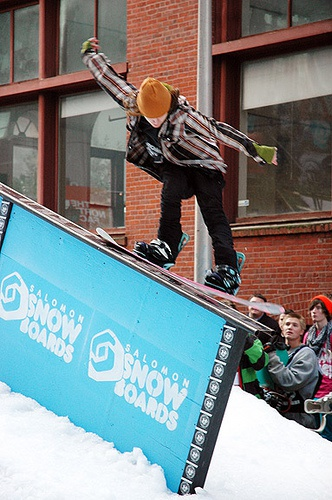Describe the objects in this image and their specific colors. I can see people in maroon, black, darkgray, gray, and brown tones, people in maroon, black, gray, darkgray, and teal tones, people in maroon, black, darkgray, and gray tones, snowboard in maroon, lavender, darkgray, lightpink, and pink tones, and people in maroon, black, lightgray, lightpink, and brown tones in this image. 